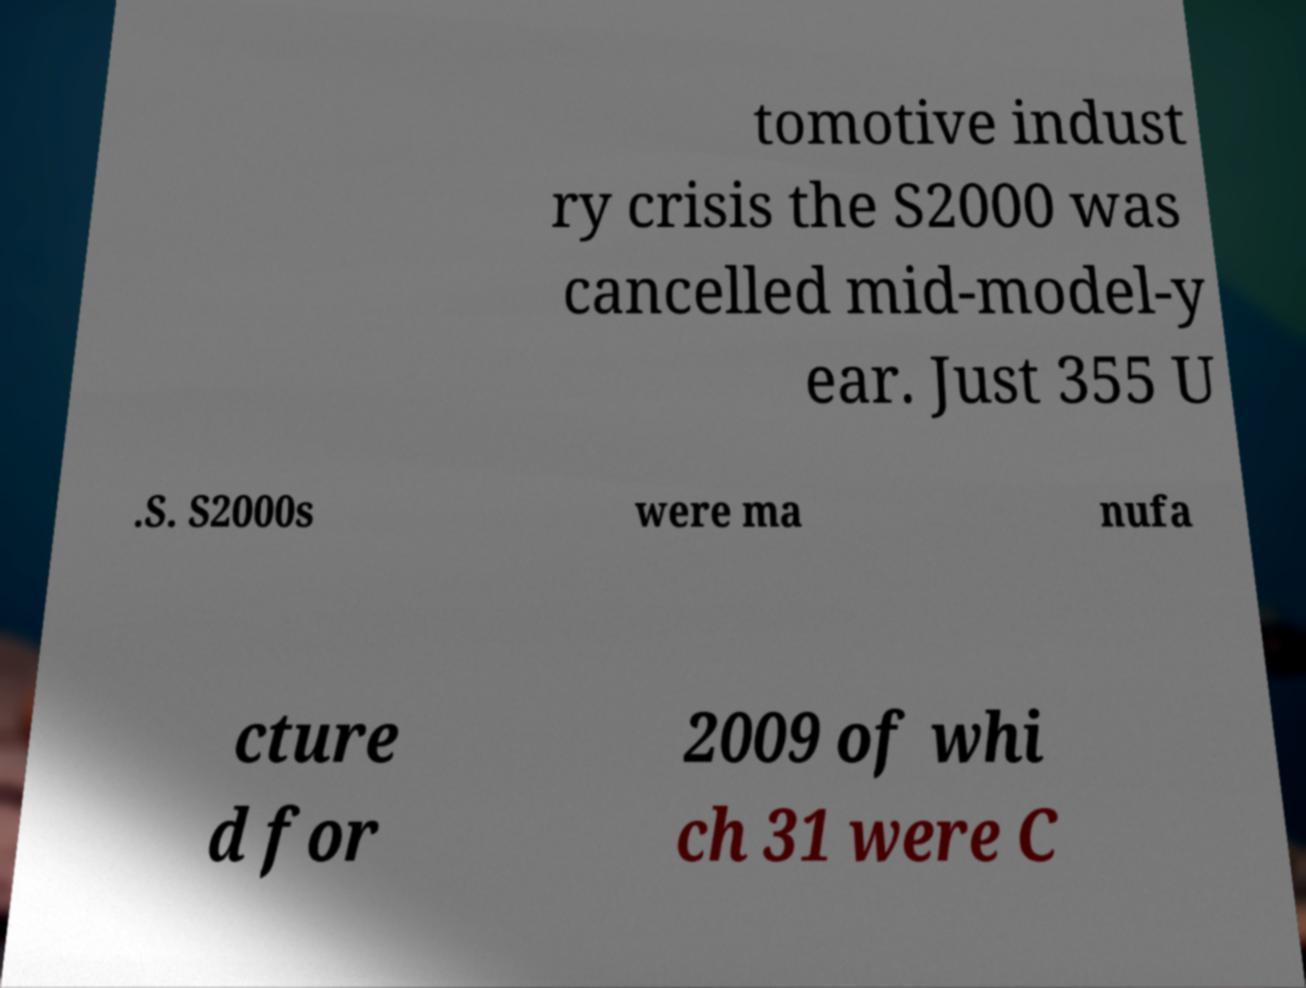Could you extract and type out the text from this image? tomotive indust ry crisis the S2000 was cancelled mid-model-y ear. Just 355 U .S. S2000s were ma nufa cture d for 2009 of whi ch 31 were C 